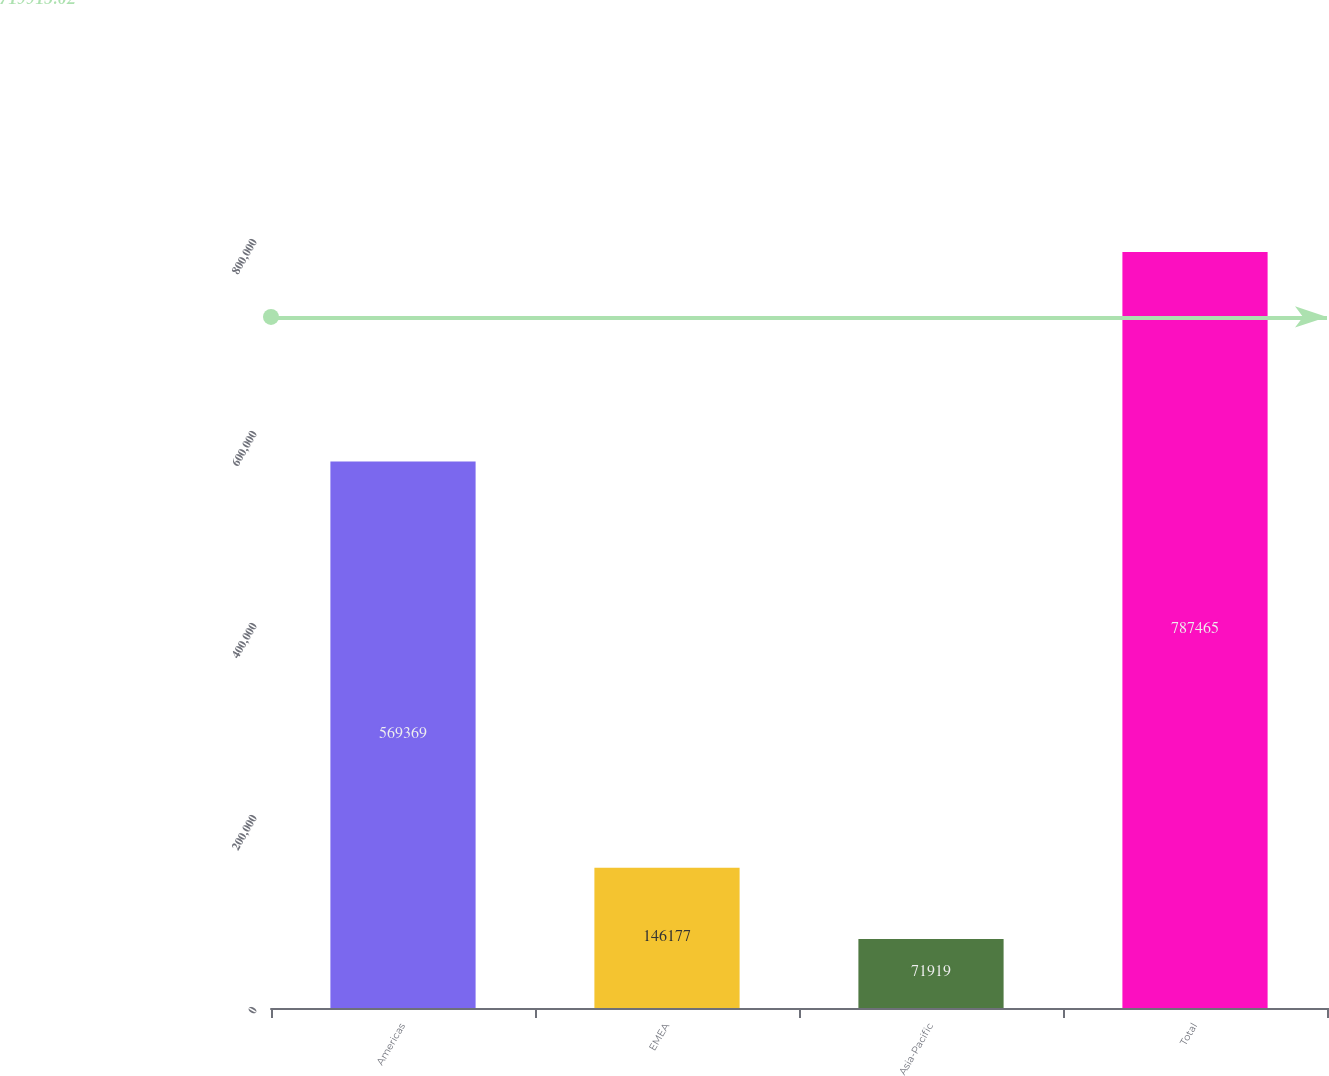<chart> <loc_0><loc_0><loc_500><loc_500><bar_chart><fcel>Americas<fcel>EMEA<fcel>Asia-Pacific<fcel>Total<nl><fcel>569369<fcel>146177<fcel>71919<fcel>787465<nl></chart> 